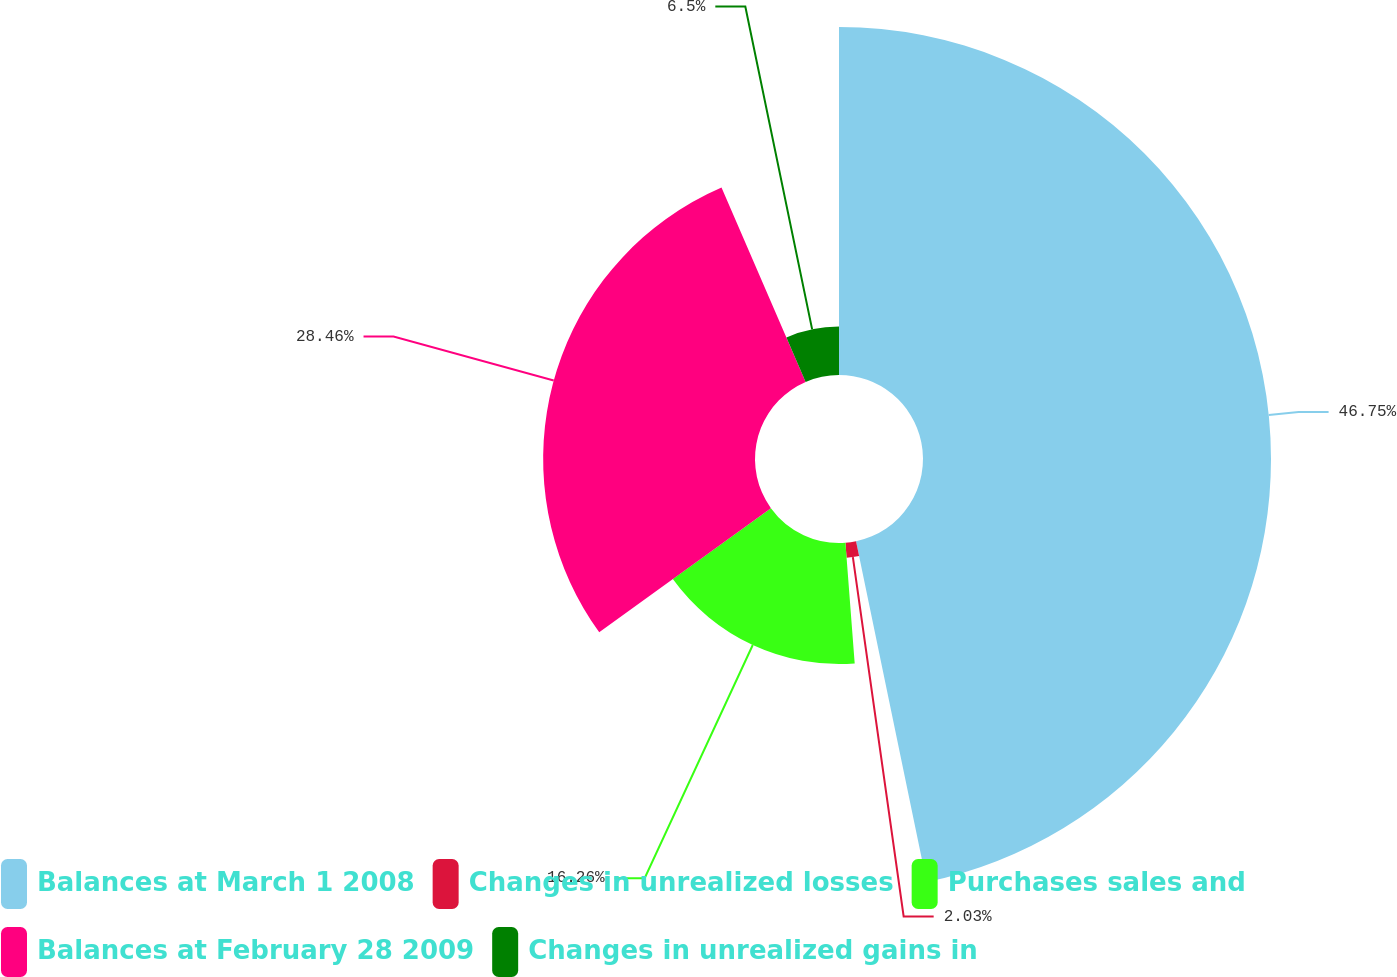Convert chart. <chart><loc_0><loc_0><loc_500><loc_500><pie_chart><fcel>Balances at March 1 2008<fcel>Changes in unrealized losses<fcel>Purchases sales and<fcel>Balances at February 28 2009<fcel>Changes in unrealized gains in<nl><fcel>46.75%<fcel>2.03%<fcel>16.26%<fcel>28.46%<fcel>6.5%<nl></chart> 